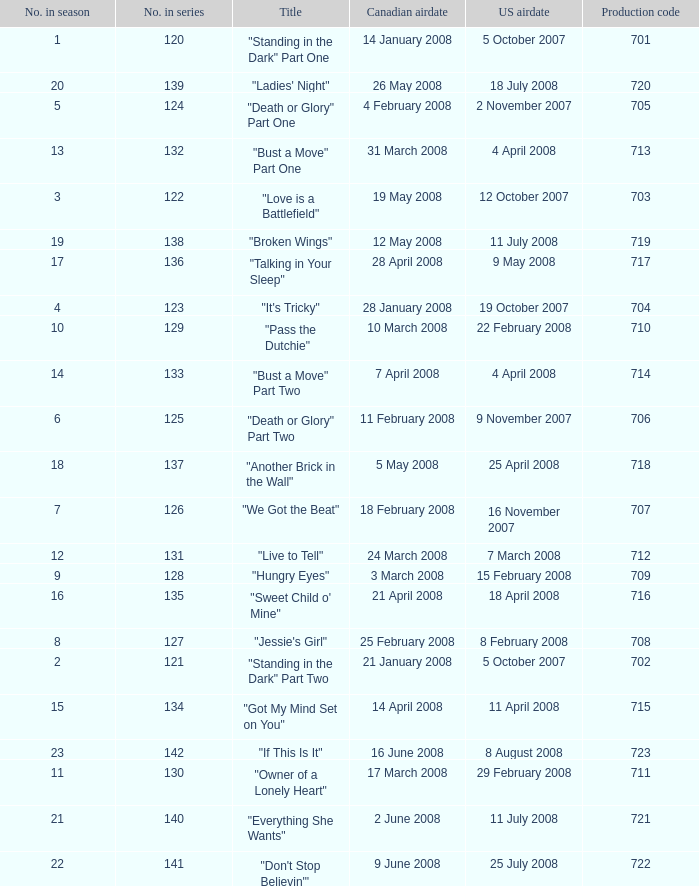The canadian airdate of 11 february 2008 applied to what series number? 1.0. 